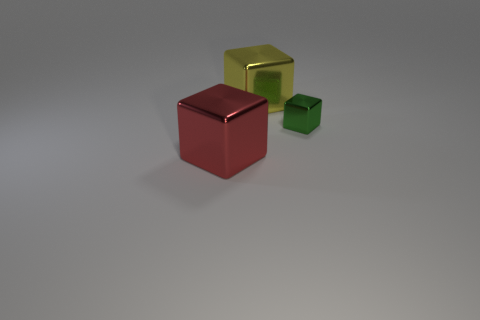What number of other tiny green things are the same shape as the small green thing?
Ensure brevity in your answer.  0. There is a tiny metallic object; is its shape the same as the large thing to the right of the red object?
Give a very brief answer. Yes. Is there another large thing made of the same material as the yellow object?
Offer a terse response. Yes. Is there any other thing that has the same material as the green cube?
Offer a very short reply. Yes. There is a cube that is right of the object behind the tiny metal thing; what is it made of?
Ensure brevity in your answer.  Metal. How big is the thing to the right of the large shiny block on the right side of the block to the left of the yellow metallic cube?
Keep it short and to the point. Small. How many other objects are there of the same shape as the small object?
Offer a terse response. 2. Does the cube that is behind the green cube have the same color as the shiny object that is on the left side of the big yellow object?
Offer a terse response. No. What color is the metal thing that is the same size as the red block?
Give a very brief answer. Yellow. Are there any large shiny blocks of the same color as the small block?
Ensure brevity in your answer.  No. 